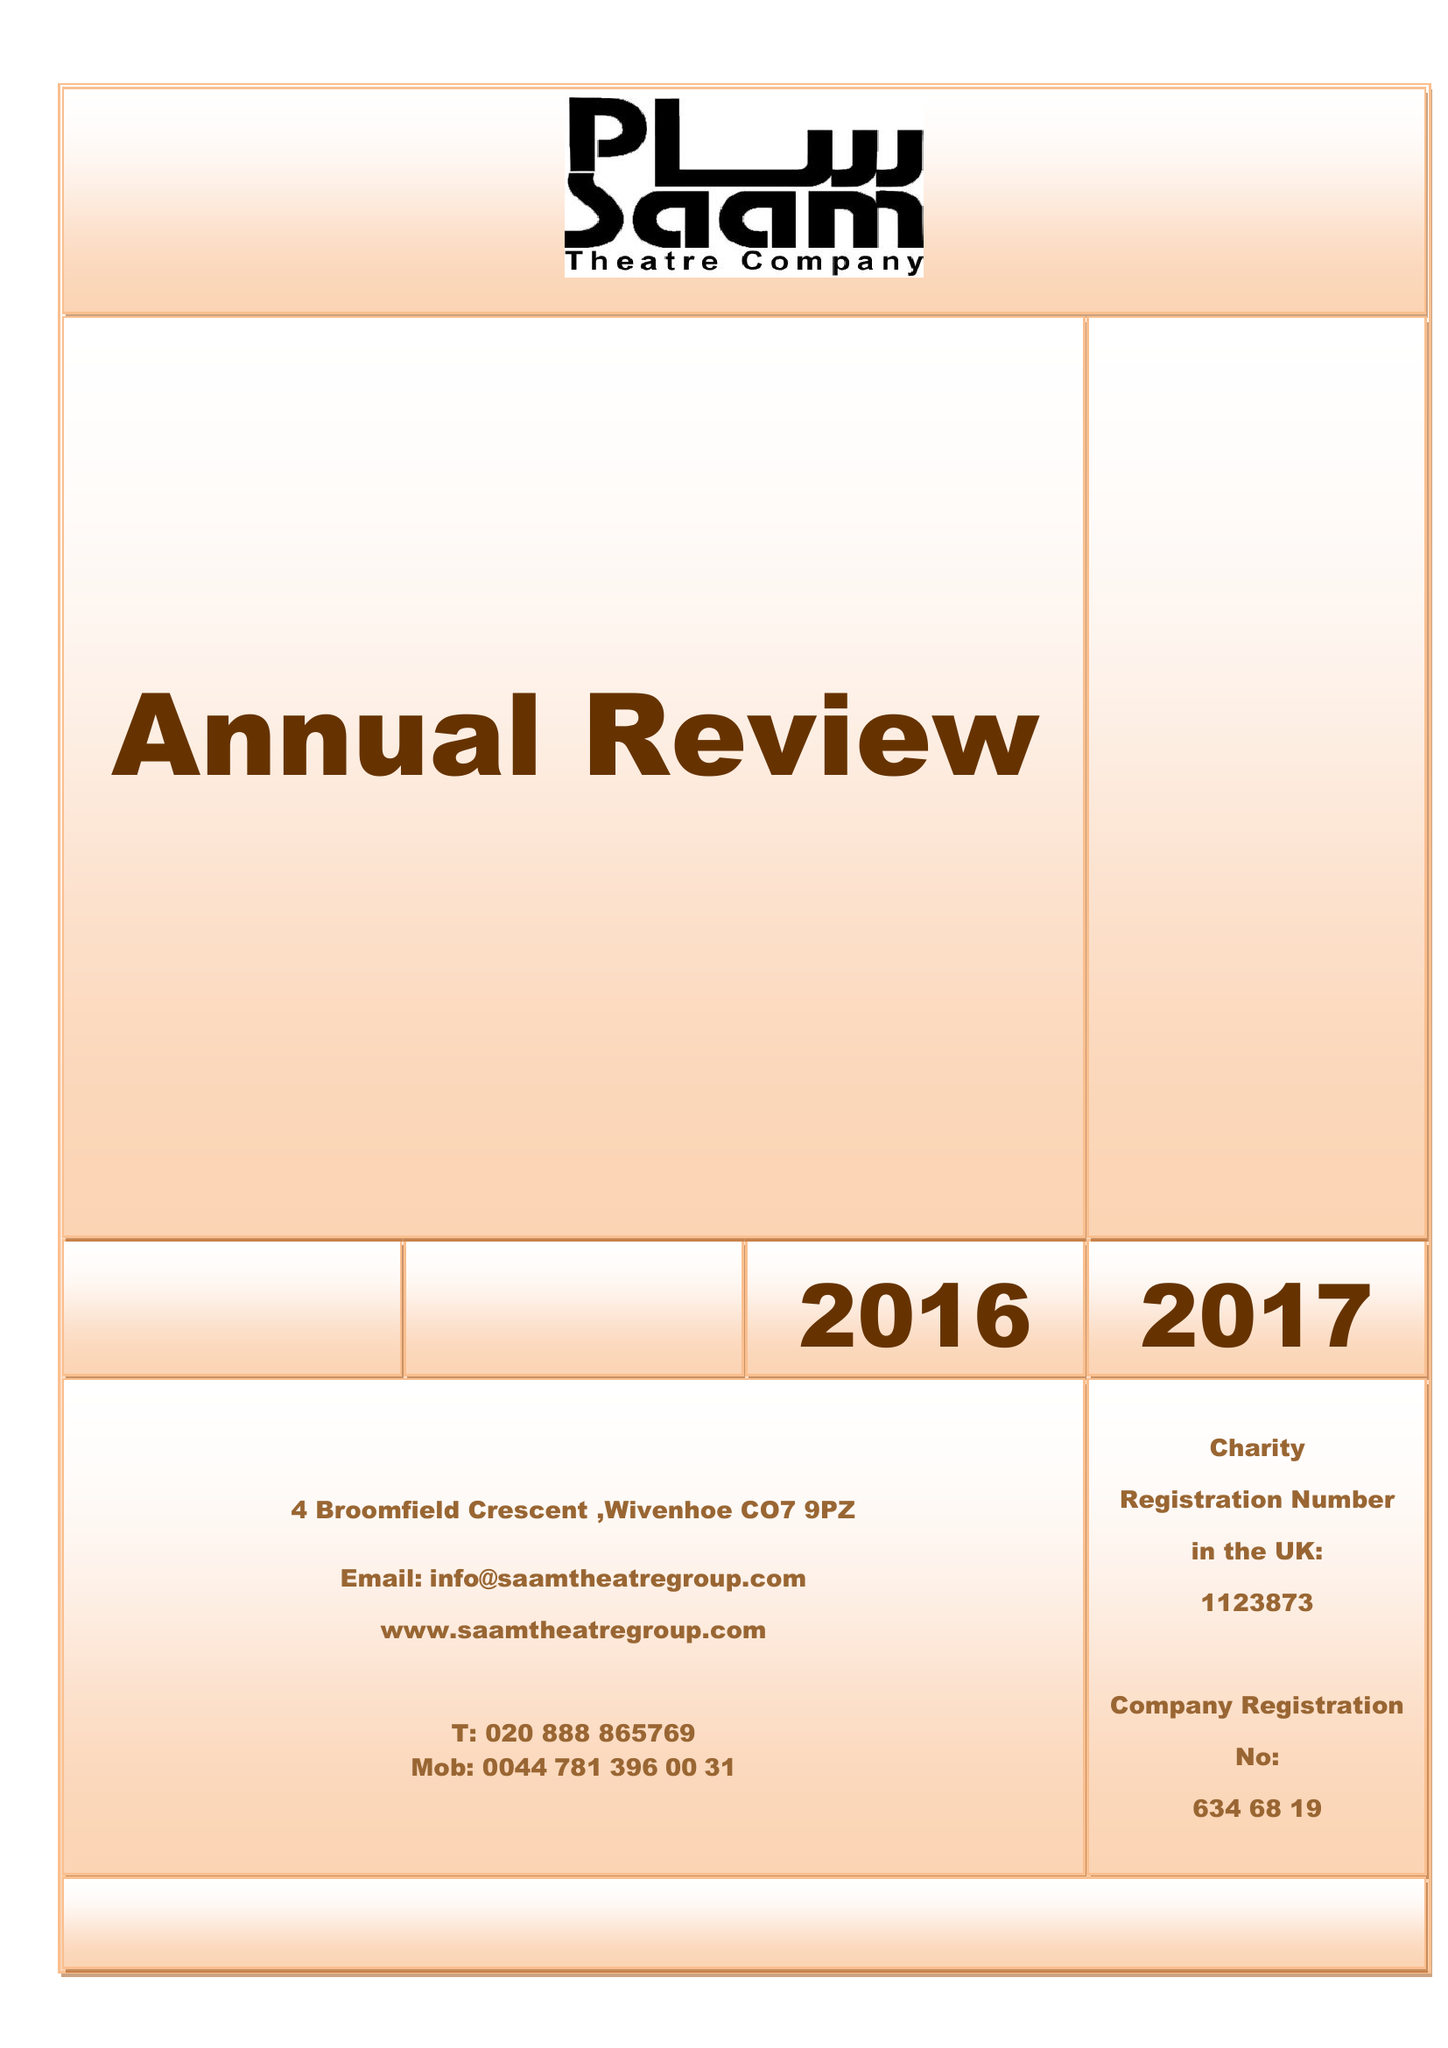What is the value for the address__postcode?
Answer the question using a single word or phrase. CO7 9PZ 